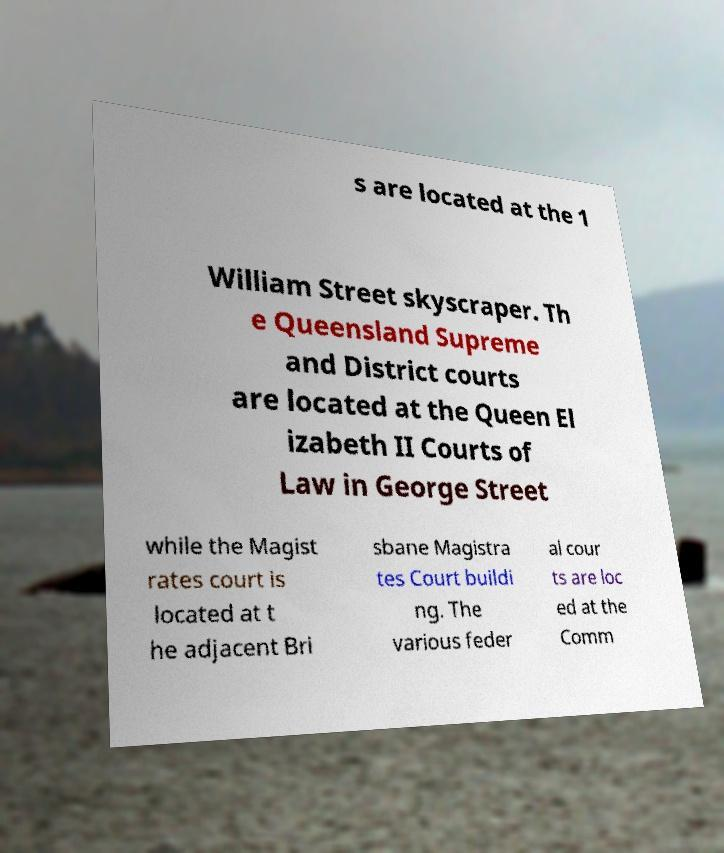Can you accurately transcribe the text from the provided image for me? s are located at the 1 William Street skyscraper. Th e Queensland Supreme and District courts are located at the Queen El izabeth II Courts of Law in George Street while the Magist rates court is located at t he adjacent Bri sbane Magistra tes Court buildi ng. The various feder al cour ts are loc ed at the Comm 